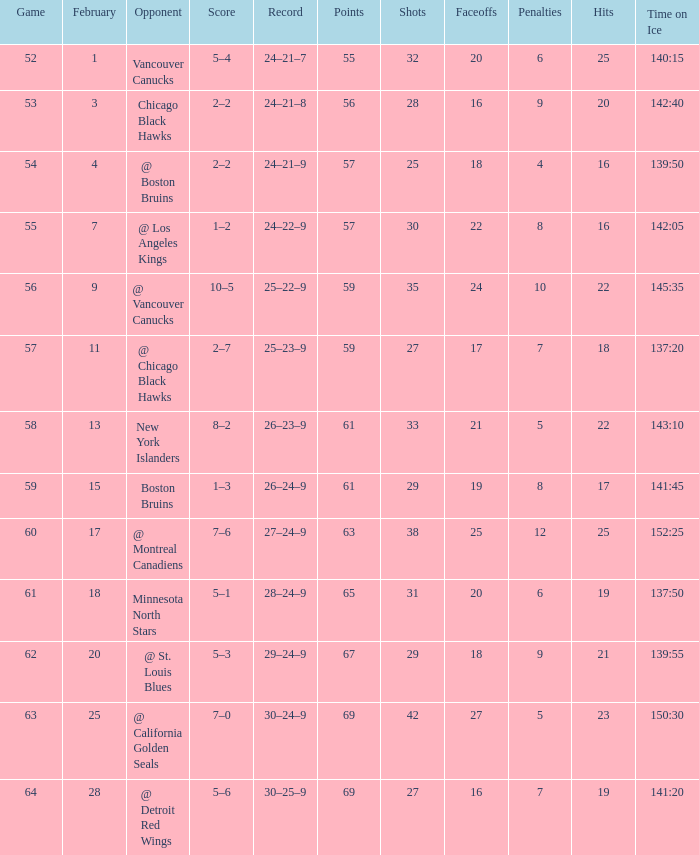How many february games had a record of 29–24–9? 20.0. 